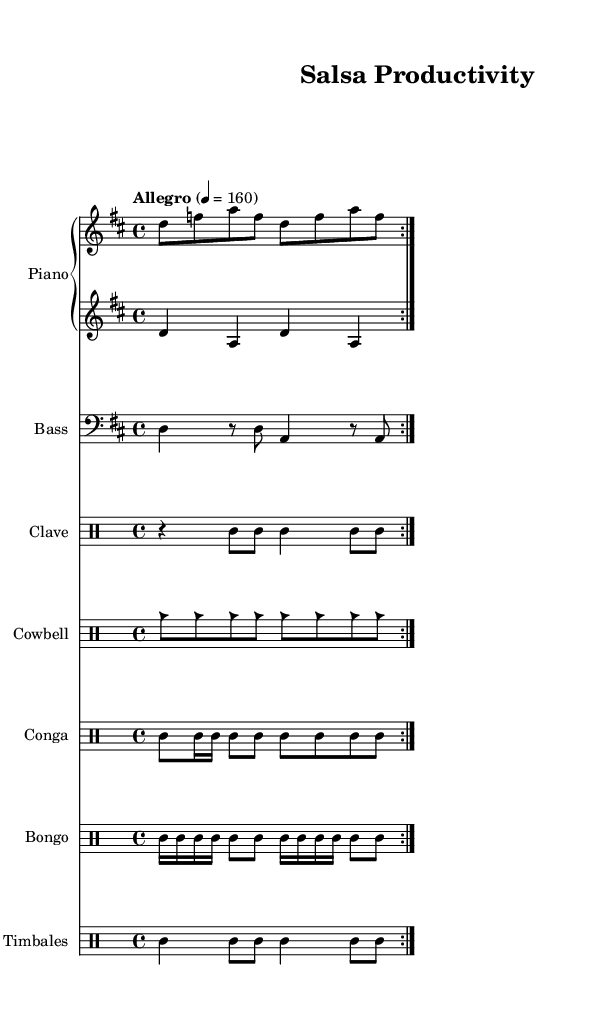What is the key signature of this music? The key signature is indicated by the sharp symbols found at the beginning of the staff. Counting the sharps, there are two sharps, which corresponds to the key of D major.
Answer: D major What is the time signature of this music? The time signature is located at the beginning of the staff, indicated by the fraction-like structure. Here, it shows 4 over 4, which is common time.
Answer: 4/4 What is the tempo marking of this piece? The tempo marking appears at the beginning of the score and is written as "Allegro" followed by a number indicating beats per minute. This marking indicates a lively speed of 160 beats per minute.
Answer: Allegro 4 = 160 How many times is the piano right-hand part repeated? The repeat structure is visually indicated by the "volta" signs, which direct the musician to repeat the section. The indication shows it is to be repeated two times.
Answer: 2 times What instruments are included in this piece? The instruments are named above their respective staves. They include Piano, Bass, Clave, Cowbell, Conga, Bongo, and Timbales.
Answer: Piano, Bass, Clave, Cowbell, Conga, Bongo, Timbales What is a defining characteristic of the salsa rhythm in the percussion part? In the drum parts, there’s a clear emphasis on syncopation and a combination of short and long notes, often accenting particular beats of the measure. This characteristic is typical in salsa music and provides the driving energy for the rhythm.
Answer: Syncopation 